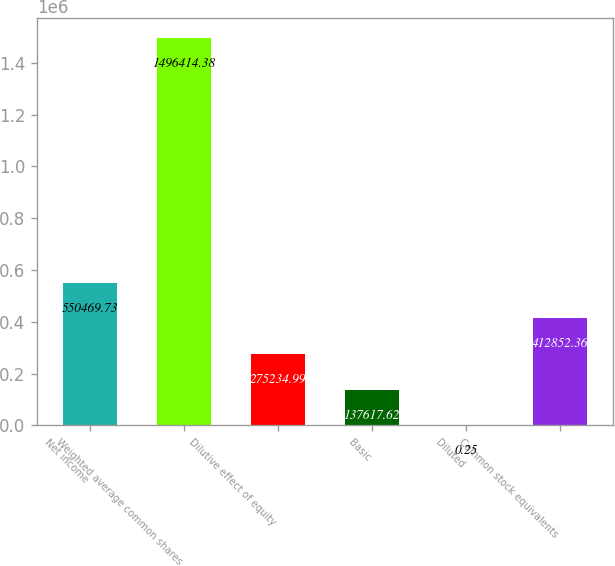<chart> <loc_0><loc_0><loc_500><loc_500><bar_chart><fcel>Net income<fcel>Weighted average common shares<fcel>Dilutive effect of equity<fcel>Basic<fcel>Diluted<fcel>Common stock equivalents<nl><fcel>550470<fcel>1.49641e+06<fcel>275235<fcel>137618<fcel>0.25<fcel>412852<nl></chart> 